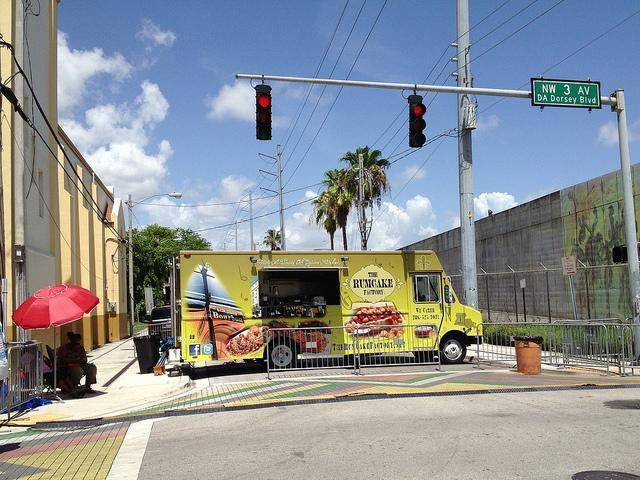What is the yellow truck doing?
Answer the question by selecting the correct answer among the 4 following choices.
Options: Selling food, extinguishing fire, repairing ground, delivering mail. Selling food. 